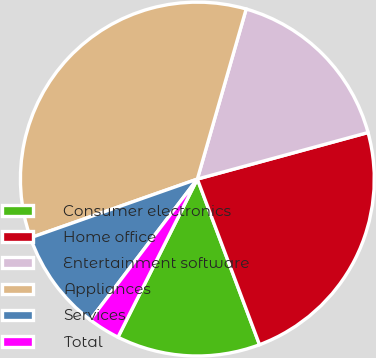Convert chart to OTSL. <chart><loc_0><loc_0><loc_500><loc_500><pie_chart><fcel>Consumer electronics<fcel>Home office<fcel>Entertainment software<fcel>Appliances<fcel>Services<fcel>Total<nl><fcel>13.12%<fcel>23.52%<fcel>16.31%<fcel>34.83%<fcel>9.27%<fcel>2.94%<nl></chart> 